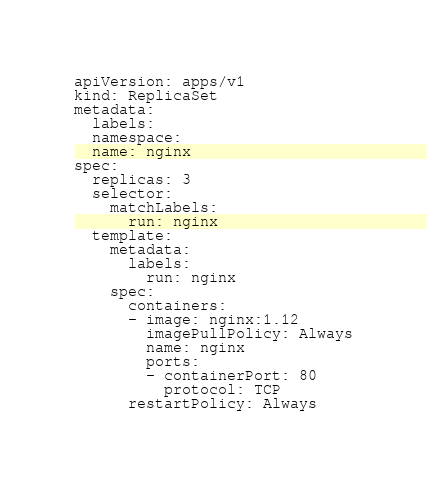Convert code to text. <code><loc_0><loc_0><loc_500><loc_500><_YAML_>apiVersion: apps/v1
kind: ReplicaSet
metadata:
  labels:
  namespace:
  name: nginx
spec:
  replicas: 3
  selector:
    matchLabels:
      run: nginx
  template:
    metadata:
      labels:
        run: nginx
    spec:
      containers:
      - image: nginx:1.12
        imagePullPolicy: Always
        name: nginx
        ports:
        - containerPort: 80
          protocol: TCP
      restartPolicy: Always
</code> 